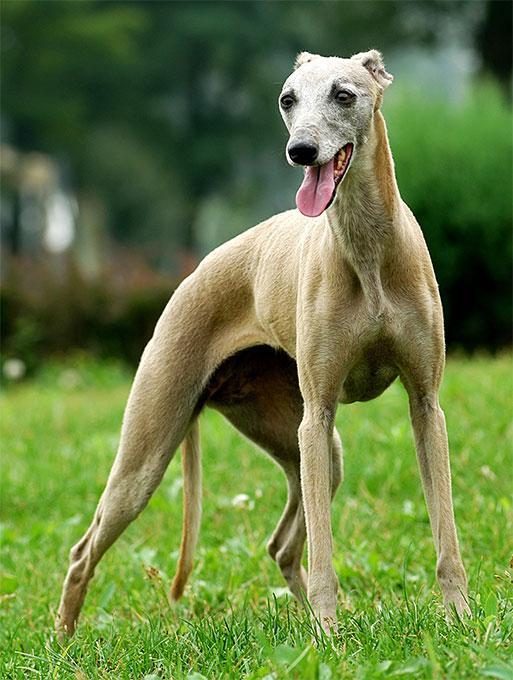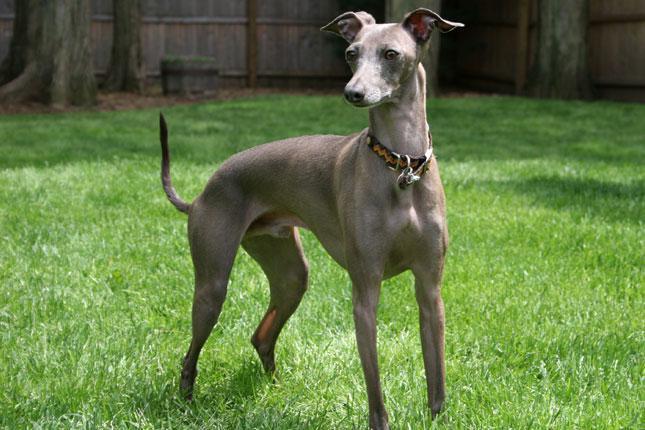The first image is the image on the left, the second image is the image on the right. Considering the images on both sides, is "The Italian Greyhound dog is standing in each image." valid? Answer yes or no. Yes. The first image is the image on the left, the second image is the image on the right. Analyze the images presented: Is the assertion "There are two dogs standing and facing the same direction as the other." valid? Answer yes or no. Yes. 